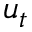<formula> <loc_0><loc_0><loc_500><loc_500>u _ { t }</formula> 